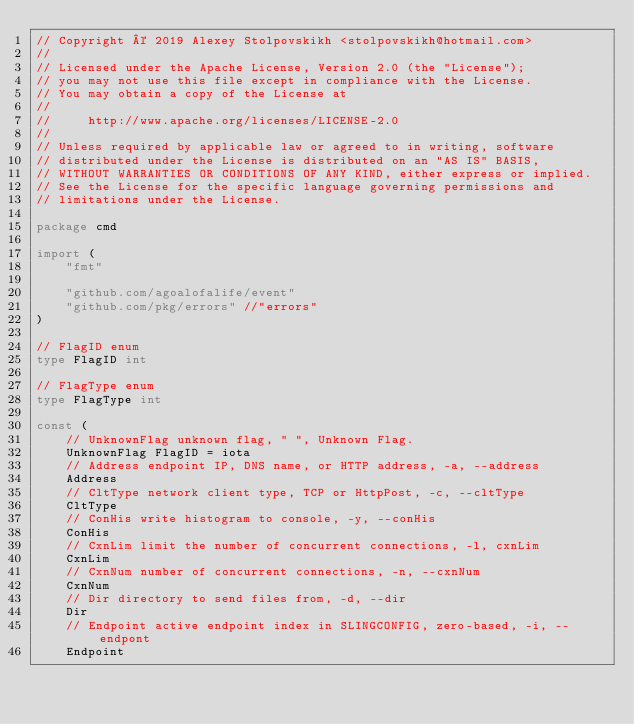<code> <loc_0><loc_0><loc_500><loc_500><_Go_>// Copyright © 2019 Alexey Stolpovskikh <stolpovskikh@hotmail.com>
//
// Licensed under the Apache License, Version 2.0 (the "License");
// you may not use this file except in compliance with the License.
// You may obtain a copy of the License at
//
//     http://www.apache.org/licenses/LICENSE-2.0
//
// Unless required by applicable law or agreed to in writing, software
// distributed under the License is distributed on an "AS IS" BASIS,
// WITHOUT WARRANTIES OR CONDITIONS OF ANY KIND, either express or implied.
// See the License for the specific language governing permissions and
// limitations under the License.

package cmd

import (
	"fmt"

	"github.com/agoalofalife/event"
	"github.com/pkg/errors" //"errors"
)

// FlagID enum
type FlagID int

// FlagType enum
type FlagType int

const (
	// UnknownFlag unknown flag, " ", Unknown Flag.
	UnknownFlag FlagID = iota
	// Address endpoint IP, DNS name, or HTTP address, -a, --address
	Address
	// CltType network client type, TCP or HttpPost, -c, --cltType
	CltType
	// ConHis write histogram to console, -y, --conHis
	ConHis
	// CxnLim limit the number of concurrent connections, -l, cxnLim
	CxnLim
	// CxnNum number of concurrent connections, -n, --cxnNum
	CxnNum
	// Dir directory to send files from, -d, --dir
	Dir
	// Endpoint active endpoint index in SLINGCONFIG, zero-based, -i, --endpont
	Endpoint</code> 